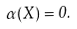Convert formula to latex. <formula><loc_0><loc_0><loc_500><loc_500>\alpha ( X ) = 0 .</formula> 